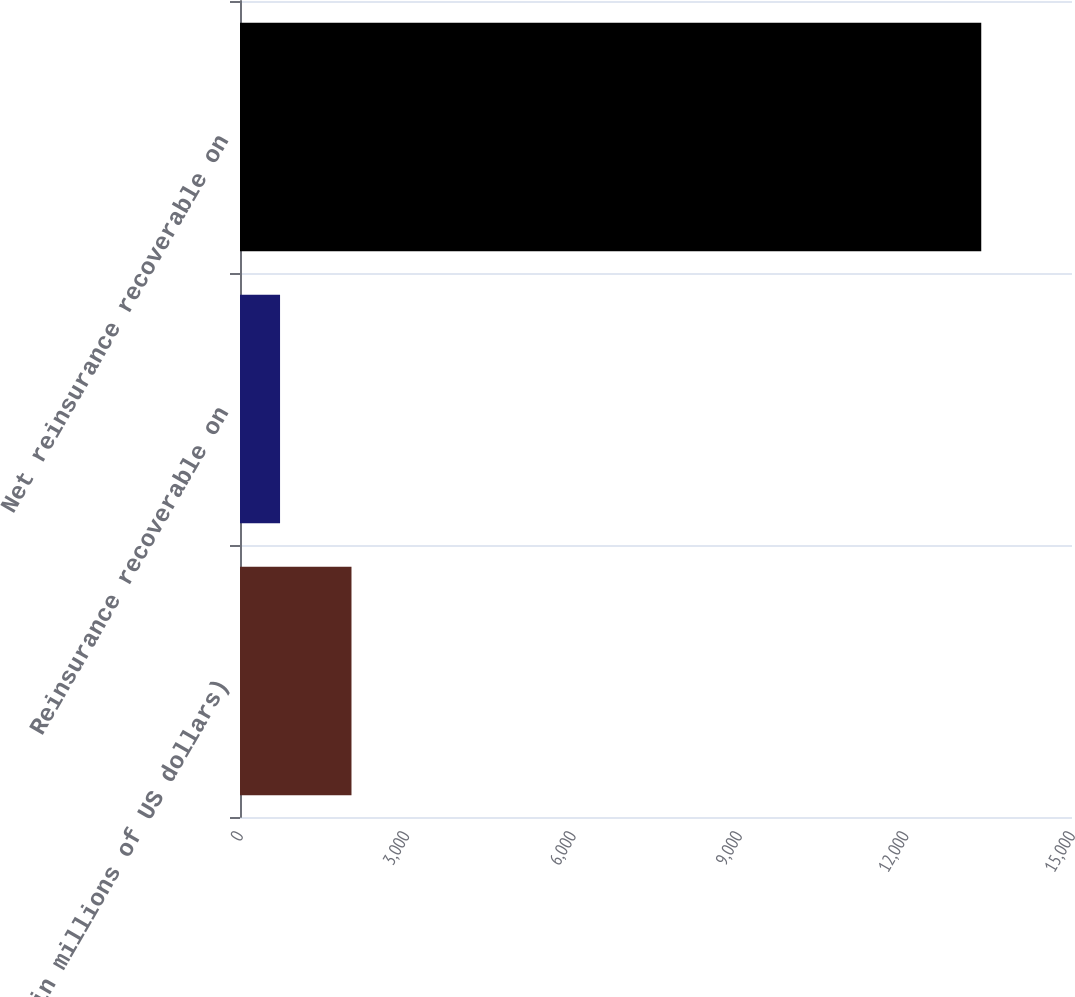Convert chart to OTSL. <chart><loc_0><loc_0><loc_500><loc_500><bar_chart><fcel>(in millions of US dollars)<fcel>Reinsurance recoverable on<fcel>Net reinsurance recoverable on<nl><fcel>2010<fcel>722<fcel>13363.9<nl></chart> 